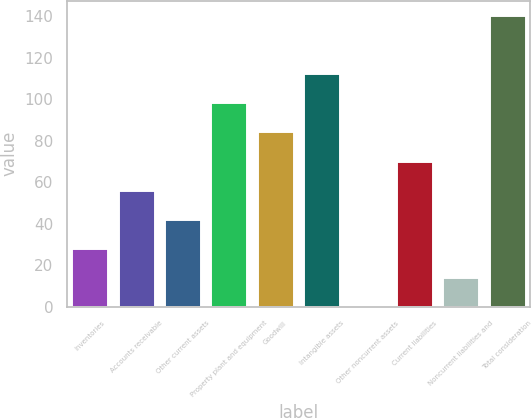<chart> <loc_0><loc_0><loc_500><loc_500><bar_chart><fcel>Inventories<fcel>Accounts receivable<fcel>Other current assets<fcel>Property plant and equipment<fcel>Goodwill<fcel>Intangible assets<fcel>Other noncurrent assets<fcel>Current liabilities<fcel>Noncurrent liabilities and<fcel>Total consideration<nl><fcel>28.34<fcel>56.38<fcel>42.36<fcel>98.44<fcel>84.42<fcel>112.46<fcel>0.3<fcel>70.4<fcel>14.32<fcel>140.5<nl></chart> 